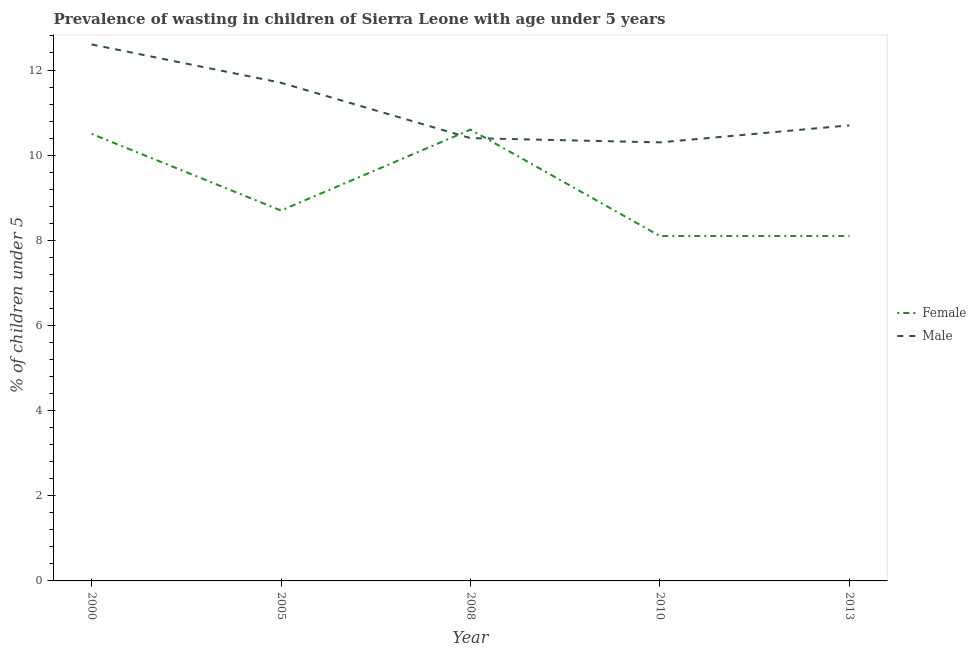Does the line corresponding to percentage of undernourished male children intersect with the line corresponding to percentage of undernourished female children?
Your answer should be very brief. Yes. Is the number of lines equal to the number of legend labels?
Offer a terse response. Yes. What is the percentage of undernourished male children in 2013?
Ensure brevity in your answer.  10.7. Across all years, what is the maximum percentage of undernourished male children?
Provide a short and direct response. 12.6. Across all years, what is the minimum percentage of undernourished male children?
Keep it short and to the point. 10.3. In which year was the percentage of undernourished female children minimum?
Ensure brevity in your answer.  2010. What is the total percentage of undernourished female children in the graph?
Make the answer very short. 46. What is the difference between the percentage of undernourished female children in 2000 and that in 2008?
Your answer should be very brief. -0.1. What is the difference between the percentage of undernourished male children in 2005 and the percentage of undernourished female children in 2000?
Make the answer very short. 1.2. What is the average percentage of undernourished female children per year?
Provide a short and direct response. 9.2. In the year 2013, what is the difference between the percentage of undernourished female children and percentage of undernourished male children?
Ensure brevity in your answer.  -2.6. In how many years, is the percentage of undernourished male children greater than 7.6 %?
Give a very brief answer. 5. What is the ratio of the percentage of undernourished male children in 2010 to that in 2013?
Make the answer very short. 0.96. Is the difference between the percentage of undernourished male children in 2008 and 2013 greater than the difference between the percentage of undernourished female children in 2008 and 2013?
Give a very brief answer. No. What is the difference between the highest and the second highest percentage of undernourished female children?
Make the answer very short. 0.1. What is the difference between the highest and the lowest percentage of undernourished female children?
Ensure brevity in your answer.  2.5. In how many years, is the percentage of undernourished female children greater than the average percentage of undernourished female children taken over all years?
Your answer should be compact. 2. Does the percentage of undernourished female children monotonically increase over the years?
Provide a succinct answer. No. Is the percentage of undernourished male children strictly less than the percentage of undernourished female children over the years?
Offer a terse response. No. How many years are there in the graph?
Keep it short and to the point. 5. Does the graph contain any zero values?
Provide a short and direct response. No. Does the graph contain grids?
Give a very brief answer. No. Where does the legend appear in the graph?
Your answer should be compact. Center right. How many legend labels are there?
Your answer should be compact. 2. What is the title of the graph?
Provide a short and direct response. Prevalence of wasting in children of Sierra Leone with age under 5 years. What is the label or title of the X-axis?
Provide a succinct answer. Year. What is the label or title of the Y-axis?
Provide a succinct answer.  % of children under 5. What is the  % of children under 5 in Male in 2000?
Provide a short and direct response. 12.6. What is the  % of children under 5 in Female in 2005?
Give a very brief answer. 8.7. What is the  % of children under 5 in Male in 2005?
Provide a short and direct response. 11.7. What is the  % of children under 5 of Female in 2008?
Offer a terse response. 10.6. What is the  % of children under 5 of Male in 2008?
Your response must be concise. 10.4. What is the  % of children under 5 in Female in 2010?
Provide a succinct answer. 8.1. What is the  % of children under 5 in Male in 2010?
Your answer should be compact. 10.3. What is the  % of children under 5 in Female in 2013?
Your answer should be compact. 8.1. What is the  % of children under 5 of Male in 2013?
Your answer should be very brief. 10.7. Across all years, what is the maximum  % of children under 5 of Female?
Provide a succinct answer. 10.6. Across all years, what is the maximum  % of children under 5 in Male?
Offer a very short reply. 12.6. Across all years, what is the minimum  % of children under 5 in Female?
Offer a terse response. 8.1. Across all years, what is the minimum  % of children under 5 of Male?
Provide a succinct answer. 10.3. What is the total  % of children under 5 of Male in the graph?
Make the answer very short. 55.7. What is the difference between the  % of children under 5 in Female in 2000 and that in 2005?
Keep it short and to the point. 1.8. What is the difference between the  % of children under 5 of Male in 2000 and that in 2008?
Provide a succinct answer. 2.2. What is the difference between the  % of children under 5 in Female in 2000 and that in 2010?
Keep it short and to the point. 2.4. What is the difference between the  % of children under 5 in Female in 2000 and that in 2013?
Keep it short and to the point. 2.4. What is the difference between the  % of children under 5 in Male in 2000 and that in 2013?
Make the answer very short. 1.9. What is the difference between the  % of children under 5 in Female in 2005 and that in 2008?
Give a very brief answer. -1.9. What is the difference between the  % of children under 5 in Female in 2005 and that in 2010?
Provide a succinct answer. 0.6. What is the difference between the  % of children under 5 in Male in 2005 and that in 2010?
Keep it short and to the point. 1.4. What is the difference between the  % of children under 5 in Male in 2008 and that in 2010?
Make the answer very short. 0.1. What is the difference between the  % of children under 5 in Male in 2008 and that in 2013?
Your answer should be compact. -0.3. What is the difference between the  % of children under 5 of Female in 2000 and the  % of children under 5 of Male in 2008?
Offer a very short reply. 0.1. What is the difference between the  % of children under 5 of Female in 2000 and the  % of children under 5 of Male in 2013?
Ensure brevity in your answer.  -0.2. What is the difference between the  % of children under 5 of Female in 2005 and the  % of children under 5 of Male in 2008?
Your answer should be very brief. -1.7. What is the average  % of children under 5 of Male per year?
Make the answer very short. 11.14. In the year 2010, what is the difference between the  % of children under 5 of Female and  % of children under 5 of Male?
Keep it short and to the point. -2.2. What is the ratio of the  % of children under 5 in Female in 2000 to that in 2005?
Your response must be concise. 1.21. What is the ratio of the  % of children under 5 in Male in 2000 to that in 2005?
Make the answer very short. 1.08. What is the ratio of the  % of children under 5 of Female in 2000 to that in 2008?
Offer a terse response. 0.99. What is the ratio of the  % of children under 5 of Male in 2000 to that in 2008?
Provide a succinct answer. 1.21. What is the ratio of the  % of children under 5 of Female in 2000 to that in 2010?
Your answer should be compact. 1.3. What is the ratio of the  % of children under 5 in Male in 2000 to that in 2010?
Your answer should be compact. 1.22. What is the ratio of the  % of children under 5 of Female in 2000 to that in 2013?
Your answer should be very brief. 1.3. What is the ratio of the  % of children under 5 in Male in 2000 to that in 2013?
Your response must be concise. 1.18. What is the ratio of the  % of children under 5 of Female in 2005 to that in 2008?
Offer a very short reply. 0.82. What is the ratio of the  % of children under 5 of Male in 2005 to that in 2008?
Ensure brevity in your answer.  1.12. What is the ratio of the  % of children under 5 of Female in 2005 to that in 2010?
Offer a very short reply. 1.07. What is the ratio of the  % of children under 5 of Male in 2005 to that in 2010?
Your answer should be very brief. 1.14. What is the ratio of the  % of children under 5 in Female in 2005 to that in 2013?
Your answer should be very brief. 1.07. What is the ratio of the  % of children under 5 of Male in 2005 to that in 2013?
Give a very brief answer. 1.09. What is the ratio of the  % of children under 5 in Female in 2008 to that in 2010?
Your response must be concise. 1.31. What is the ratio of the  % of children under 5 of Male in 2008 to that in 2010?
Keep it short and to the point. 1.01. What is the ratio of the  % of children under 5 of Female in 2008 to that in 2013?
Offer a terse response. 1.31. What is the ratio of the  % of children under 5 of Male in 2008 to that in 2013?
Make the answer very short. 0.97. What is the ratio of the  % of children under 5 of Female in 2010 to that in 2013?
Offer a very short reply. 1. What is the ratio of the  % of children under 5 of Male in 2010 to that in 2013?
Your answer should be compact. 0.96. What is the difference between the highest and the second highest  % of children under 5 in Male?
Make the answer very short. 0.9. What is the difference between the highest and the lowest  % of children under 5 in Male?
Provide a succinct answer. 2.3. 